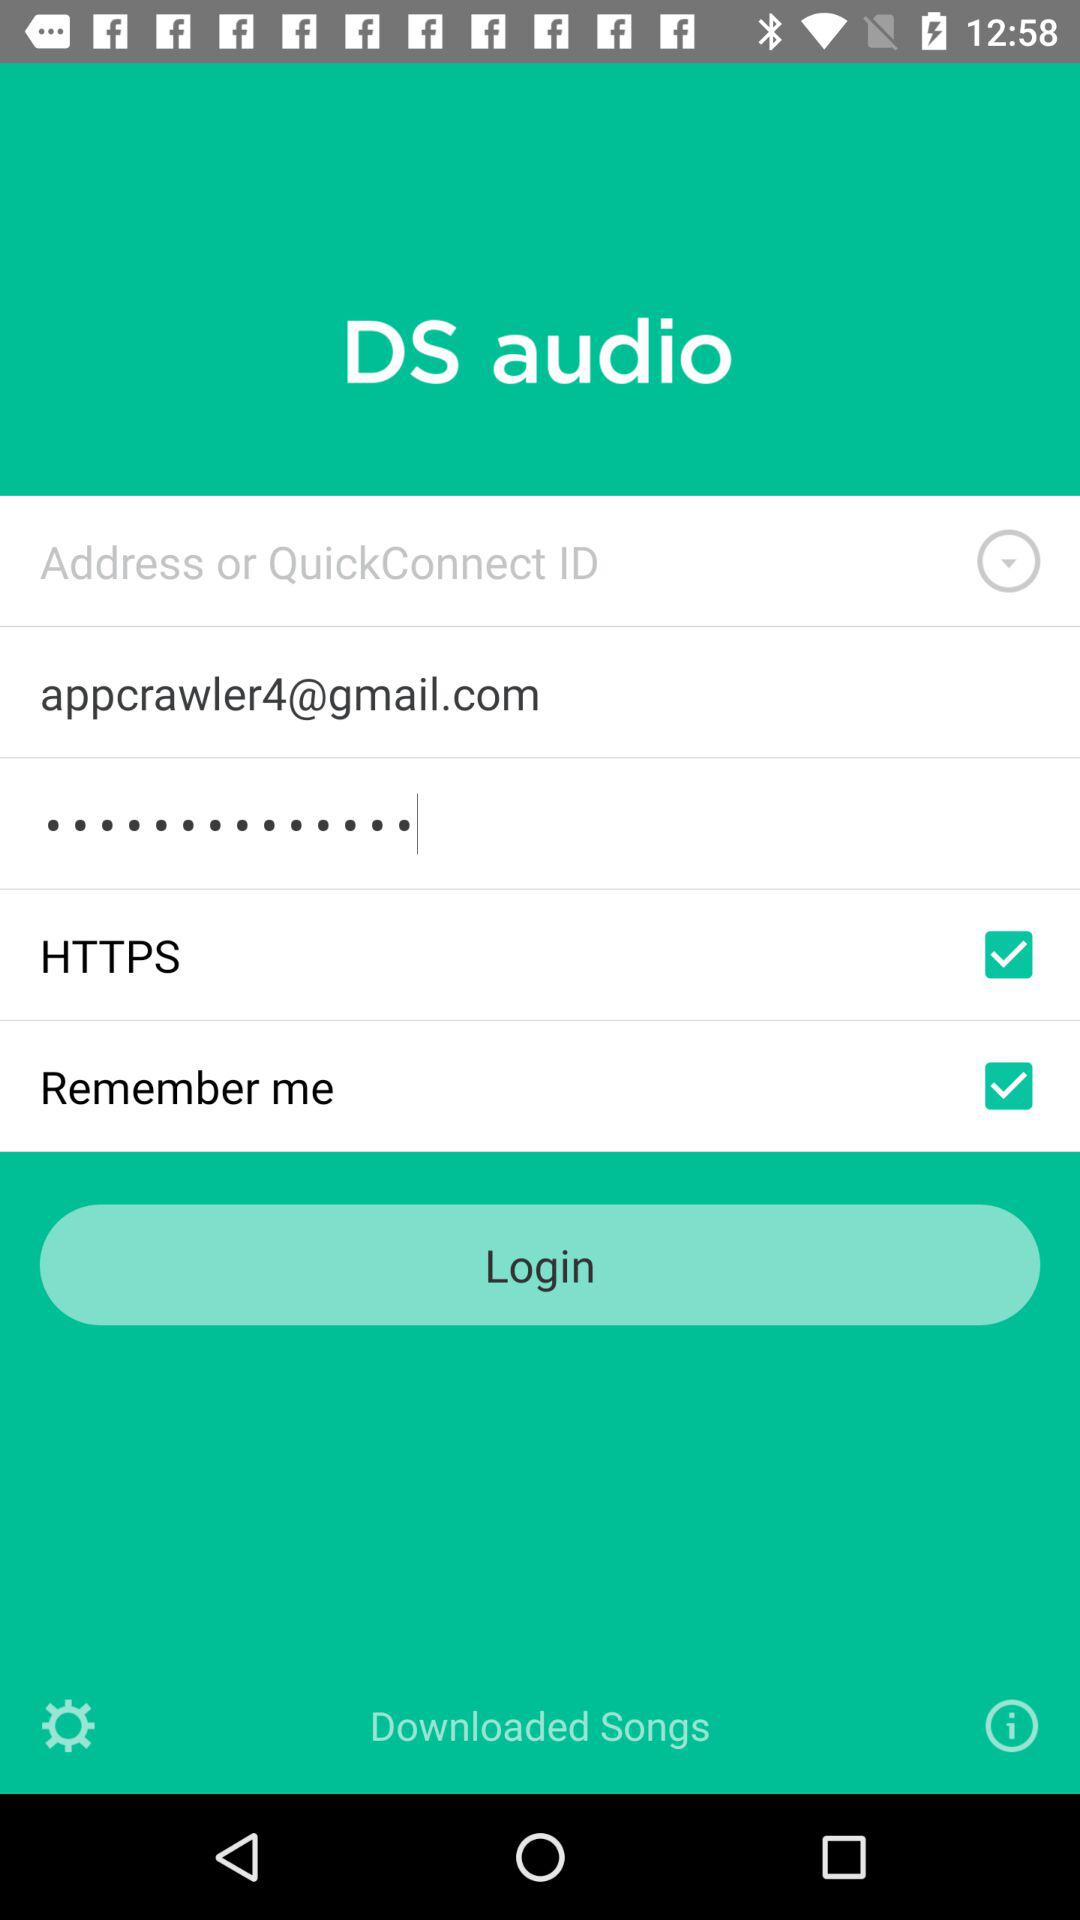How many checkboxes are present in the login form?
Answer the question using a single word or phrase. 2 